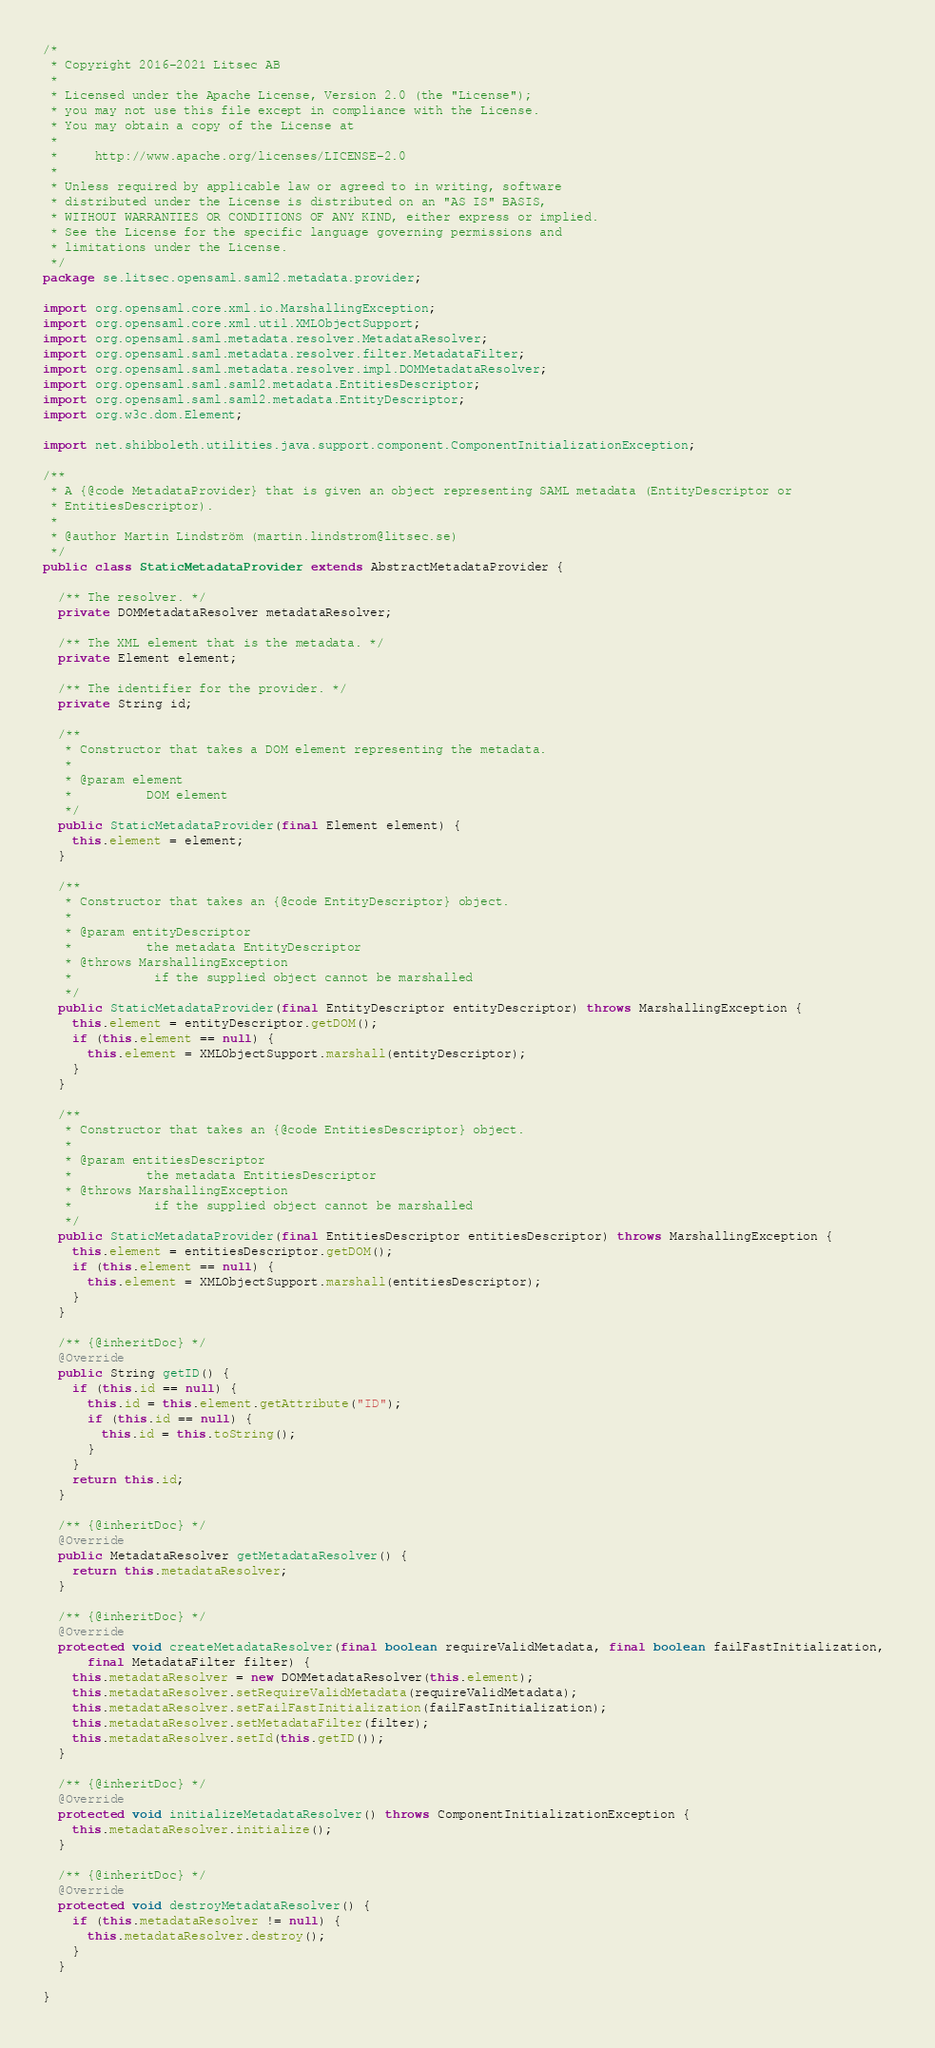<code> <loc_0><loc_0><loc_500><loc_500><_Java_>/*
 * Copyright 2016-2021 Litsec AB
 *
 * Licensed under the Apache License, Version 2.0 (the "License");
 * you may not use this file except in compliance with the License.
 * You may obtain a copy of the License at
 *
 *     http://www.apache.org/licenses/LICENSE-2.0
 *
 * Unless required by applicable law or agreed to in writing, software
 * distributed under the License is distributed on an "AS IS" BASIS,
 * WITHOUT WARRANTIES OR CONDITIONS OF ANY KIND, either express or implied.
 * See the License for the specific language governing permissions and
 * limitations under the License.
 */
package se.litsec.opensaml.saml2.metadata.provider;

import org.opensaml.core.xml.io.MarshallingException;
import org.opensaml.core.xml.util.XMLObjectSupport;
import org.opensaml.saml.metadata.resolver.MetadataResolver;
import org.opensaml.saml.metadata.resolver.filter.MetadataFilter;
import org.opensaml.saml.metadata.resolver.impl.DOMMetadataResolver;
import org.opensaml.saml.saml2.metadata.EntitiesDescriptor;
import org.opensaml.saml.saml2.metadata.EntityDescriptor;
import org.w3c.dom.Element;

import net.shibboleth.utilities.java.support.component.ComponentInitializationException;

/**
 * A {@code MetadataProvider} that is given an object representing SAML metadata (EntityDescriptor or
 * EntitiesDescriptor).
 * 
 * @author Martin Lindström (martin.lindstrom@litsec.se)
 */
public class StaticMetadataProvider extends AbstractMetadataProvider {

  /** The resolver. */
  private DOMMetadataResolver metadataResolver;

  /** The XML element that is the metadata. */
  private Element element;
  
  /** The identifier for the provider. */
  private String id;

  /**
   * Constructor that takes a DOM element representing the metadata.
   * 
   * @param element
   *          DOM element
   */
  public StaticMetadataProvider(final Element element) {
    this.element = element;
  }

  /**
   * Constructor that takes an {@code EntityDescriptor} object.
   * 
   * @param entityDescriptor
   *          the metadata EntityDescriptor
   * @throws MarshallingException
   *           if the supplied object cannot be marshalled
   */
  public StaticMetadataProvider(final EntityDescriptor entityDescriptor) throws MarshallingException {
    this.element = entityDescriptor.getDOM();
    if (this.element == null) {
      this.element = XMLObjectSupport.marshall(entityDescriptor);
    }
  }

  /**
   * Constructor that takes an {@code EntitiesDescriptor} object.
   * 
   * @param entitiesDescriptor
   *          the metadata EntitiesDescriptor
   * @throws MarshallingException
   *           if the supplied object cannot be marshalled
   */
  public StaticMetadataProvider(final EntitiesDescriptor entitiesDescriptor) throws MarshallingException {
    this.element = entitiesDescriptor.getDOM();
    if (this.element == null) {
      this.element = XMLObjectSupport.marshall(entitiesDescriptor);
    }
  }
  
  /** {@inheritDoc} */
  @Override
  public String getID() {
    if (this.id == null) {
      this.id = this.element.getAttribute("ID");
      if (this.id == null) {
        this.id = this.toString();
      }
    }
    return this.id;
  }

  /** {@inheritDoc} */
  @Override
  public MetadataResolver getMetadataResolver() {
    return this.metadataResolver;
  }

  /** {@inheritDoc} */
  @Override
  protected void createMetadataResolver(final boolean requireValidMetadata, final boolean failFastInitialization, 
      final MetadataFilter filter) {
    this.metadataResolver = new DOMMetadataResolver(this.element);
    this.metadataResolver.setRequireValidMetadata(requireValidMetadata);
    this.metadataResolver.setFailFastInitialization(failFastInitialization);
    this.metadataResolver.setMetadataFilter(filter);
    this.metadataResolver.setId(this.getID());
  }

  /** {@inheritDoc} */
  @Override
  protected void initializeMetadataResolver() throws ComponentInitializationException {
    this.metadataResolver.initialize();
  }

  /** {@inheritDoc} */
  @Override
  protected void destroyMetadataResolver() {
    if (this.metadataResolver != null) {
      this.metadataResolver.destroy();
    }
  }

}
</code> 